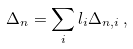Convert formula to latex. <formula><loc_0><loc_0><loc_500><loc_500>\Delta _ { n } = \sum _ { i } l _ { i } \Delta _ { n , i } \, ,</formula> 